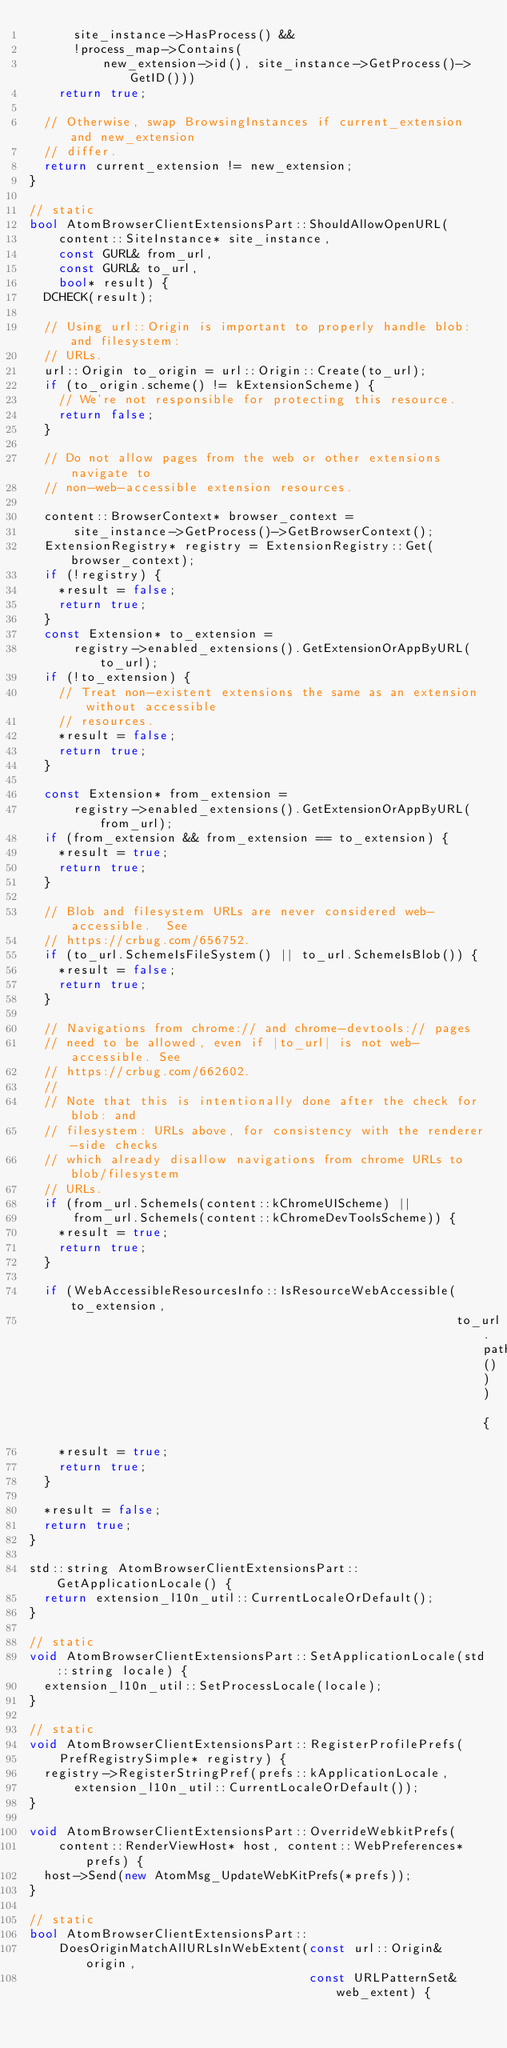Convert code to text. <code><loc_0><loc_0><loc_500><loc_500><_C++_>      site_instance->HasProcess() &&
      !process_map->Contains(
          new_extension->id(), site_instance->GetProcess()->GetID()))
    return true;

  // Otherwise, swap BrowsingInstances if current_extension and new_extension
  // differ.
  return current_extension != new_extension;
}

// static
bool AtomBrowserClientExtensionsPart::ShouldAllowOpenURL(
    content::SiteInstance* site_instance,
    const GURL& from_url,
    const GURL& to_url,
    bool* result) {
  DCHECK(result);

  // Using url::Origin is important to properly handle blob: and filesystem:
  // URLs.
  url::Origin to_origin = url::Origin::Create(to_url);
  if (to_origin.scheme() != kExtensionScheme) {
    // We're not responsible for protecting this resource.
    return false;
  }

  // Do not allow pages from the web or other extensions navigate to
  // non-web-accessible extension resources.

  content::BrowserContext* browser_context =
      site_instance->GetProcess()->GetBrowserContext();
  ExtensionRegistry* registry = ExtensionRegistry::Get(browser_context);
  if (!registry) {
    *result = false;
    return true;
  }
  const Extension* to_extension =
      registry->enabled_extensions().GetExtensionOrAppByURL(to_url);
  if (!to_extension) {
    // Treat non-existent extensions the same as an extension without accessible
    // resources.
    *result = false;
    return true;
  }

  const Extension* from_extension =
      registry->enabled_extensions().GetExtensionOrAppByURL(from_url);
  if (from_extension && from_extension == to_extension) {
    *result = true;
    return true;
  }

  // Blob and filesystem URLs are never considered web-accessible.  See
  // https://crbug.com/656752.
  if (to_url.SchemeIsFileSystem() || to_url.SchemeIsBlob()) {
    *result = false;
    return true;
  }

  // Navigations from chrome:// and chrome-devtools:// pages
  // need to be allowed, even if |to_url| is not web-accessible. See
  // https://crbug.com/662602.
  //
  // Note that this is intentionally done after the check for blob: and
  // filesystem: URLs above, for consistency with the renderer-side checks
  // which already disallow navigations from chrome URLs to blob/filesystem
  // URLs.
  if (from_url.SchemeIs(content::kChromeUIScheme) ||
      from_url.SchemeIs(content::kChromeDevToolsScheme)) {
    *result = true;
    return true;
  }

  if (WebAccessibleResourcesInfo::IsResourceWebAccessible(to_extension,
                                                          to_url.path())) {
    *result = true;
    return true;
  }

  *result = false;
  return true;
}

std::string AtomBrowserClientExtensionsPart::GetApplicationLocale() {
  return extension_l10n_util::CurrentLocaleOrDefault();
}

// static
void AtomBrowserClientExtensionsPart::SetApplicationLocale(std::string locale) {
  extension_l10n_util::SetProcessLocale(locale);
}

// static
void AtomBrowserClientExtensionsPart::RegisterProfilePrefs(
    PrefRegistrySimple* registry) {
  registry->RegisterStringPref(prefs::kApplicationLocale,
      extension_l10n_util::CurrentLocaleOrDefault());
}

void AtomBrowserClientExtensionsPart::OverrideWebkitPrefs(
    content::RenderViewHost* host, content::WebPreferences* prefs) {
  host->Send(new AtomMsg_UpdateWebKitPrefs(*prefs));
}

// static
bool AtomBrowserClientExtensionsPart::
    DoesOriginMatchAllURLsInWebExtent(const url::Origin& origin,
                                      const URLPatternSet& web_extent) {</code> 